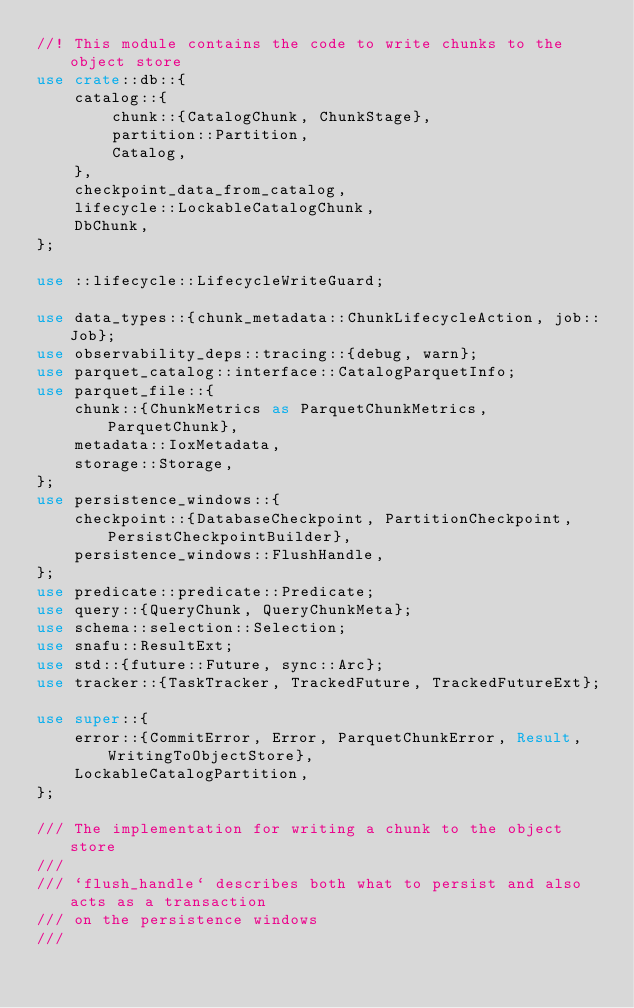<code> <loc_0><loc_0><loc_500><loc_500><_Rust_>//! This module contains the code to write chunks to the object store
use crate::db::{
    catalog::{
        chunk::{CatalogChunk, ChunkStage},
        partition::Partition,
        Catalog,
    },
    checkpoint_data_from_catalog,
    lifecycle::LockableCatalogChunk,
    DbChunk,
};

use ::lifecycle::LifecycleWriteGuard;

use data_types::{chunk_metadata::ChunkLifecycleAction, job::Job};
use observability_deps::tracing::{debug, warn};
use parquet_catalog::interface::CatalogParquetInfo;
use parquet_file::{
    chunk::{ChunkMetrics as ParquetChunkMetrics, ParquetChunk},
    metadata::IoxMetadata,
    storage::Storage,
};
use persistence_windows::{
    checkpoint::{DatabaseCheckpoint, PartitionCheckpoint, PersistCheckpointBuilder},
    persistence_windows::FlushHandle,
};
use predicate::predicate::Predicate;
use query::{QueryChunk, QueryChunkMeta};
use schema::selection::Selection;
use snafu::ResultExt;
use std::{future::Future, sync::Arc};
use tracker::{TaskTracker, TrackedFuture, TrackedFutureExt};

use super::{
    error::{CommitError, Error, ParquetChunkError, Result, WritingToObjectStore},
    LockableCatalogPartition,
};

/// The implementation for writing a chunk to the object store
///
/// `flush_handle` describes both what to persist and also acts as a transaction
/// on the persistence windows
///</code> 